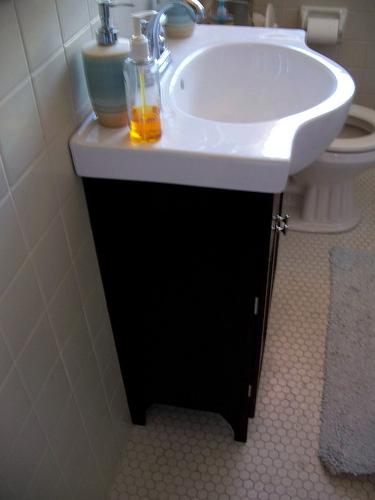Is there soap on the sink?
Answer briefly. Yes. What color is the sink?
Answer briefly. White. Is that a large sink?
Keep it brief. Yes. 